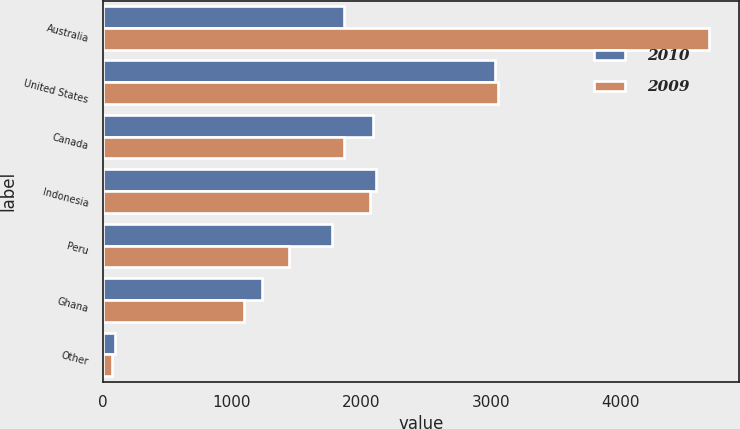Convert chart. <chart><loc_0><loc_0><loc_500><loc_500><stacked_bar_chart><ecel><fcel>Australia<fcel>United States<fcel>Canada<fcel>Indonesia<fcel>Peru<fcel>Ghana<fcel>Other<nl><fcel>2010<fcel>1869<fcel>3031<fcel>2088<fcel>2109<fcel>1772<fcel>1231<fcel>94<nl><fcel>2009<fcel>4683<fcel>3059<fcel>1869<fcel>2067<fcel>1443<fcel>1093<fcel>70<nl></chart> 